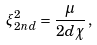Convert formula to latex. <formula><loc_0><loc_0><loc_500><loc_500>\xi _ { 2 n d } ^ { 2 } = \frac { \mu } { 2 d \chi } \, ,</formula> 